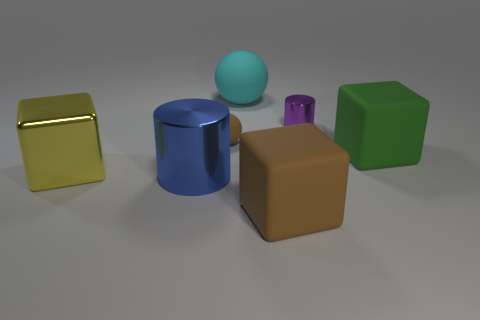Are there any other things that are the same color as the big cylinder?
Make the answer very short. No. There is a brown rubber object behind the rubber cube in front of the big cylinder; what size is it?
Ensure brevity in your answer.  Small. There is a thing that is both on the right side of the brown rubber block and to the left of the big green thing; what is its color?
Your answer should be compact. Purple. How many other objects are there of the same size as the cyan ball?
Your answer should be compact. 4. There is a cyan object; does it have the same size as the shiny cylinder that is to the left of the small brown ball?
Provide a short and direct response. Yes. There is a metallic block that is the same size as the cyan matte thing; what is its color?
Your answer should be compact. Yellow. The cyan rubber ball has what size?
Give a very brief answer. Large. Is the sphere that is in front of the purple thing made of the same material as the yellow cube?
Make the answer very short. No. Do the large cyan thing and the green object have the same shape?
Your answer should be compact. No. There is a matte thing that is in front of the block that is on the left side of the cylinder that is on the left side of the tiny purple metal object; what is its shape?
Keep it short and to the point. Cube. 